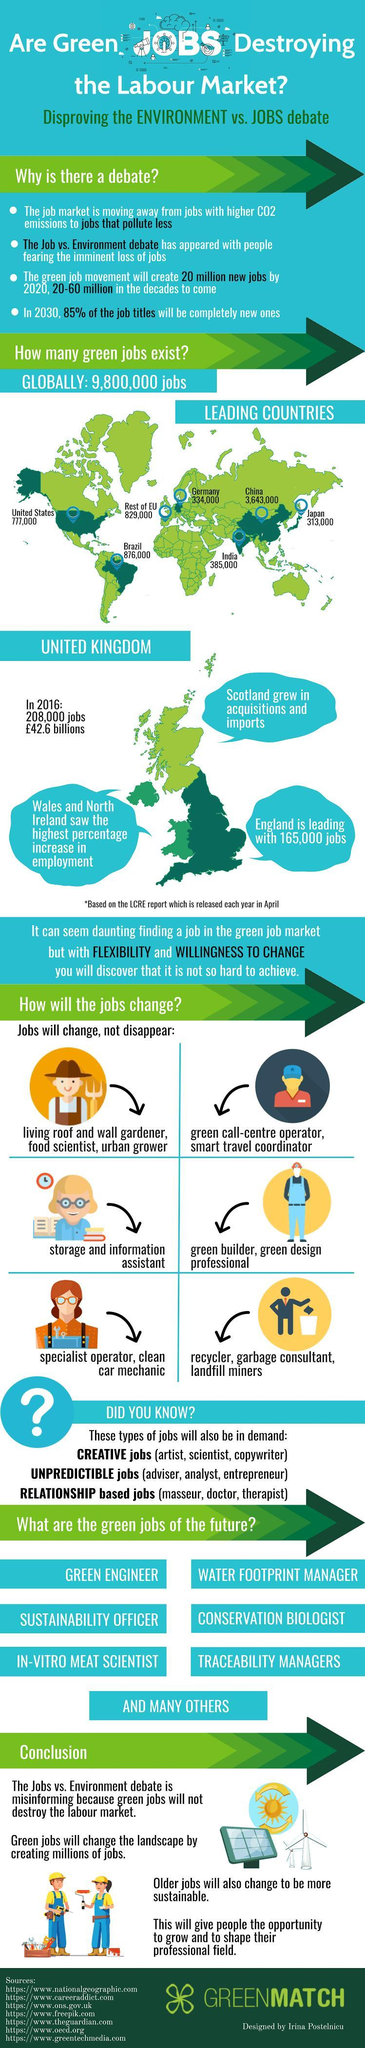What is the number of green jobs available in India?
Answer the question with a short phrase. 385,000 What is the number of green jobs available in Japan? 313,000 Which country in UK has the leading number of green jobs based on the LCRE report? England 